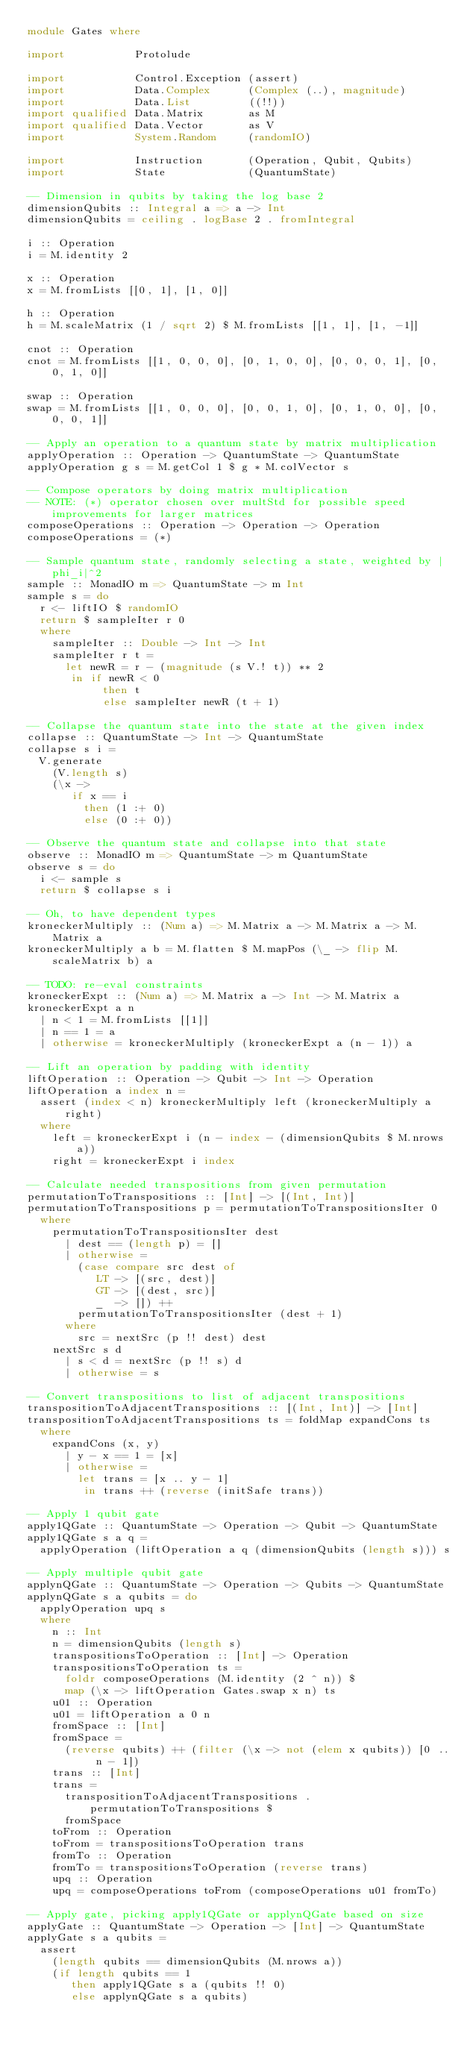<code> <loc_0><loc_0><loc_500><loc_500><_Haskell_>module Gates where

import           Protolude

import           Control.Exception (assert)
import           Data.Complex      (Complex (..), magnitude)
import           Data.List         ((!!))
import qualified Data.Matrix       as M
import qualified Data.Vector       as V
import           System.Random     (randomIO)

import           Instruction       (Operation, Qubit, Qubits)
import           State             (QuantumState)

-- Dimension in qubits by taking the log base 2
dimensionQubits :: Integral a => a -> Int
dimensionQubits = ceiling . logBase 2 . fromIntegral

i :: Operation
i = M.identity 2

x :: Operation
x = M.fromLists [[0, 1], [1, 0]]

h :: Operation
h = M.scaleMatrix (1 / sqrt 2) $ M.fromLists [[1, 1], [1, -1]]

cnot :: Operation
cnot = M.fromLists [[1, 0, 0, 0], [0, 1, 0, 0], [0, 0, 0, 1], [0, 0, 1, 0]]

swap :: Operation
swap = M.fromLists [[1, 0, 0, 0], [0, 0, 1, 0], [0, 1, 0, 0], [0, 0, 0, 1]]

-- Apply an operation to a quantum state by matrix multiplication
applyOperation :: Operation -> QuantumState -> QuantumState
applyOperation g s = M.getCol 1 $ g * M.colVector s

-- Compose operators by doing matrix multiplication
-- NOTE: (*) operator chosen over multStd for possible speed improvements for larger matrices
composeOperations :: Operation -> Operation -> Operation
composeOperations = (*)

-- Sample quantum state, randomly selecting a state, weighted by |phi_i|^2
sample :: MonadIO m => QuantumState -> m Int
sample s = do
  r <- liftIO $ randomIO
  return $ sampleIter r 0
  where
    sampleIter :: Double -> Int -> Int
    sampleIter r t =
      let newR = r - (magnitude (s V.! t)) ** 2
       in if newR < 0
            then t
            else sampleIter newR (t + 1)

-- Collapse the quantum state into the state at the given index
collapse :: QuantumState -> Int -> QuantumState
collapse s i =
  V.generate
    (V.length s)
    (\x ->
       if x == i
         then (1 :+ 0)
         else (0 :+ 0))

-- Observe the quantum state and collapse into that state
observe :: MonadIO m => QuantumState -> m QuantumState
observe s = do
  i <- sample s
  return $ collapse s i

-- Oh, to have dependent types
kroneckerMultiply :: (Num a) => M.Matrix a -> M.Matrix a -> M.Matrix a
kroneckerMultiply a b = M.flatten $ M.mapPos (\_ -> flip M.scaleMatrix b) a

-- TODO: re-eval constraints
kroneckerExpt :: (Num a) => M.Matrix a -> Int -> M.Matrix a
kroneckerExpt a n
  | n < 1 = M.fromLists [[1]]
  | n == 1 = a
  | otherwise = kroneckerMultiply (kroneckerExpt a (n - 1)) a

-- Lift an operation by padding with identity
liftOperation :: Operation -> Qubit -> Int -> Operation
liftOperation a index n =
  assert (index < n) kroneckerMultiply left (kroneckerMultiply a right)
  where
    left = kroneckerExpt i (n - index - (dimensionQubits $ M.nrows a))
    right = kroneckerExpt i index

-- Calculate needed transpositions from given permutation
permutationToTranspositions :: [Int] -> [(Int, Int)]
permutationToTranspositions p = permutationToTranspositionsIter 0
  where
    permutationToTranspositionsIter dest
      | dest == (length p) = []
      | otherwise =
        (case compare src dest of
           LT -> [(src, dest)]
           GT -> [(dest, src)]
           _  -> []) ++
        permutationToTranspositionsIter (dest + 1)
      where
        src = nextSrc (p !! dest) dest
    nextSrc s d
      | s < d = nextSrc (p !! s) d
      | otherwise = s

-- Convert transpositions to list of adjacent transpositions
transpositionToAdjacentTranspositions :: [(Int, Int)] -> [Int]
transpositionToAdjacentTranspositions ts = foldMap expandCons ts
  where
    expandCons (x, y)
      | y - x == 1 = [x]
      | otherwise =
        let trans = [x .. y - 1]
         in trans ++ (reverse (initSafe trans))

-- Apply 1 qubit gate
apply1QGate :: QuantumState -> Operation -> Qubit -> QuantumState
apply1QGate s a q =
  applyOperation (liftOperation a q (dimensionQubits (length s))) s

-- Apply multiple qubit gate
applynQGate :: QuantumState -> Operation -> Qubits -> QuantumState
applynQGate s a qubits = do
  applyOperation upq s
  where
    n :: Int
    n = dimensionQubits (length s)
    transpositionsToOperation :: [Int] -> Operation
    transpositionsToOperation ts =
      foldr composeOperations (M.identity (2 ^ n)) $
      map (\x -> liftOperation Gates.swap x n) ts
    u01 :: Operation
    u01 = liftOperation a 0 n
    fromSpace :: [Int]
    fromSpace =
      (reverse qubits) ++ (filter (\x -> not (elem x qubits)) [0 .. n - 1])
    trans :: [Int]
    trans =
      transpositionToAdjacentTranspositions . permutationToTranspositions $
      fromSpace
    toFrom :: Operation
    toFrom = transpositionsToOperation trans
    fromTo :: Operation
    fromTo = transpositionsToOperation (reverse trans)
    upq :: Operation
    upq = composeOperations toFrom (composeOperations u01 fromTo)

-- Apply gate, picking apply1QGate or applynQGate based on size
applyGate :: QuantumState -> Operation -> [Int] -> QuantumState
applyGate s a qubits =
  assert
    (length qubits == dimensionQubits (M.nrows a))
    (if length qubits == 1
       then apply1QGate s a (qubits !! 0)
       else applynQGate s a qubits)
</code> 